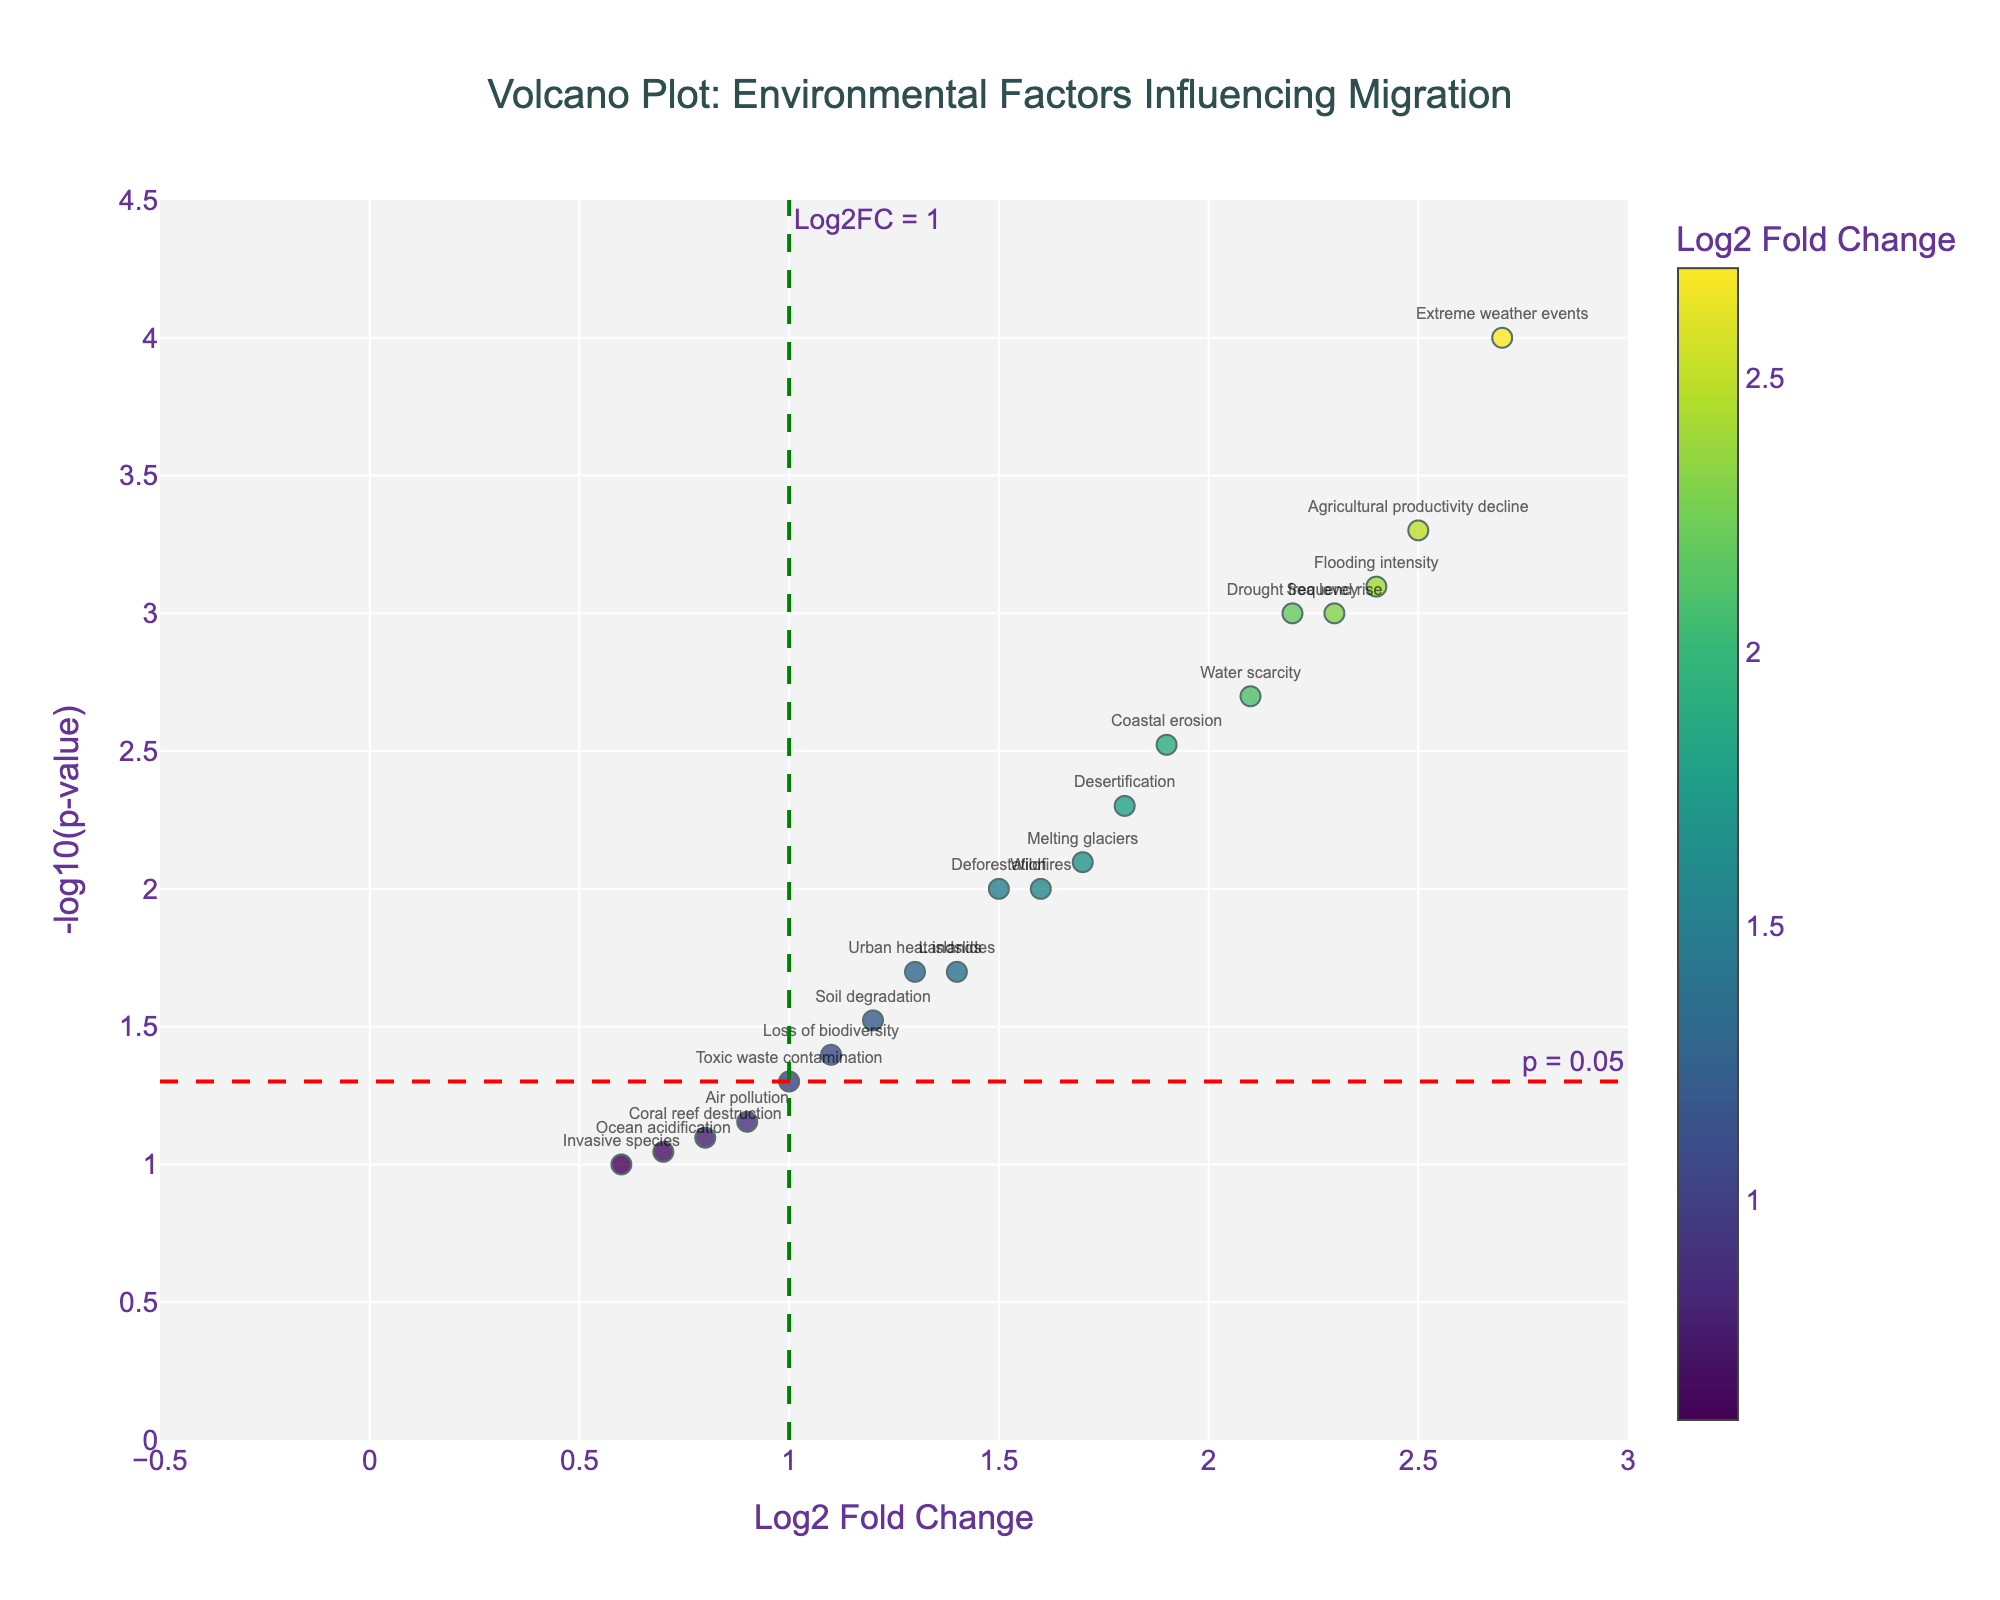What is the title of the plot? The title is found at the top center of the plot. It indicates the main theme or subject being depicted.
Answer: "Volcano Plot: Environmental Factors Influencing Migration" Which environmental factor has the highest fold change? To find the highest fold change, locate the most rightward point along the x-axis, i.e., the highest Log2 Fold Change. This point corresponds to "Agricultural productivity decline" with a Log2 Fold Change of 2.5.
Answer: Agricultural productivity decline Which environmental factor has the lowest p-value? The lowest p-value corresponds to the highest point on the y-axis, thanks to the -log10(p-value) transformation. "Extreme weather events" is the highest, indicating the lowest p-value of 0.0001.
Answer: Extreme weather events Identify the environmental factors with a Log2 Fold Change greater than 2 and a p-value less than 0.005. Look for points with Log2 Fold Change > 2 (right of the green dashed vertical line at x=2) and -log10(p-value) > 2.30 (above the red dashed horizontal line at y=-log10(0.005)). These are "Extreme weather events," "Agricultural productivity decline," "Drought frequency," and "Flooding intensity."
Answer: Extreme weather events, Agricultural productivity decline, Drought frequency, Flooding intensity Which environmental factors have a p-value greater than 0.05 and Log2 Fold Change less than 1? Points satisfying p-value > 0.05 have -log10(p-value) < 1.30 (below the red dashed line). Log2 Fold Change < 1 corresponds to values left of the green dashed line at x=1. This results in "Air pollution," "Ocean acidification," "Invasive species," and "Coral reef destruction."
Answer: Air pollution, Ocean acidification, Invasive species, Coral reef destruction How many environmental factors have a significant fold change (Log2 Fold Change > 1) with a p-value ≤ 0.05? Significant fold change > 1 (points to the right of the green dashed vertical line) and p-value ≤ 0.05 (-log10(p-value) ≥ 1.30, above the red dashed horizontal line). There are 12 such factors: "Sea level rise," "Desertification," "Deforestation," "Extreme weather events," "Water scarcity," "Coastal erosion," "Agricultural productivity decline," "Urban heat islands," "Melting glaciers," "Drought frequency," "Flooding intensity," and "Wildfires."
Answer: 12 What relationship, if any, do you observe between the magnitude of fold change and p-value? In a Volcano plot, typically as Log2 Fold Change increases, p-value tends to decrease (indicating stronger statistical significance). Points with high fold changes are often associated with low p-values (higher -log10(p-value)), and this trend is visible in the plot.
Answer: Higher fold change often coincides with lower p-values Compare the p-values of "Deforestation" and "Wildfires." Which one is more significant? Check the -log10(p-value) values for both points. "Deforestation" falls around 2 and "Wildfires" falls slightly above 2. Higher -log10(p-value) means lower p-value and more significance. Thus, "Wildfires" is more significant.
Answer: Wildfires What does the red dashed horizontal line represent? It represents the threshold for statistical significance at p-value = 0.05. Points above this line are considered statistically significant (p ≤ 0.05).
Answer: p = 0.05 For the environmental factor "Toxic waste contamination," provide its Log2 Fold Change and p-value. Locate "Toxic waste contamination" in the plot or hover information. It shows Log2 Fold Change around 1 and -log10(p-value) around 1.30, translating back to a p-value of approximately 0.05.
Answer: Log2 Fold Change: 1.0, p-value: 0.05 